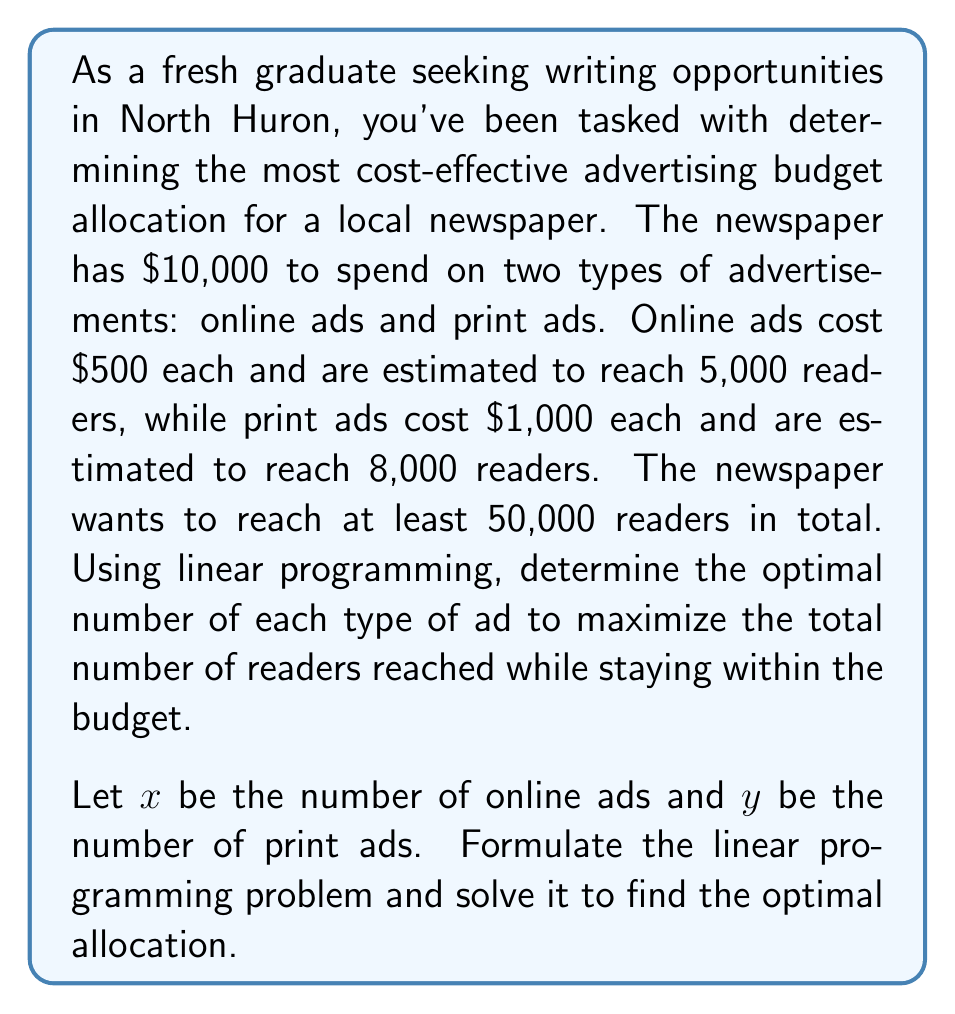Could you help me with this problem? To solve this linear programming problem, we'll follow these steps:

1. Define the objective function:
   Maximize $Z = 5000x + 8000y$ (total readers reached)

2. Identify the constraints:
   Budget constraint: $500x + 1000y \leq 10000$
   Minimum readers constraint: $5000x + 8000y \geq 50000$
   Non-negativity constraints: $x \geq 0$, $y \geq 0$

3. Graph the feasible region:
   We'll plot the constraints on a coordinate system with $x$ on the horizontal axis and $y$ on the vertical axis.

   [asy]
   import geometry;
   
   size(200);
   
   xlimits(0,25);
   ylimits(0,15);
   
   xaxis("x",Ticks());
   yaxis("y",Ticks());
   
   path budget = (0,10)--(20,0);
   path readers = (10,0)--(0,6.25);
   
   draw(budget,blue);
   draw(readers,red);
   
   label("Budget constraint",(-1,11),blue);
   label("Readers constraint",(12,5),red);
   
   fill((10,0)--(10,5)--(5,5)--(0,6.25)--(0,10)--(10,10)--cycle,palegreen+opacity(0.3));
   
   dot((10,5));
   label("(10,5)",(10,5),SE);
   [/asy]

4. Identify the corner points of the feasible region:
   (0,10), (10,5), (10,0), (0,6.25)

5. Evaluate the objective function at each corner point:
   At (0,10): $Z = 5000(0) + 8000(10) = 80000$
   At (10,5): $Z = 5000(10) + 8000(5) = 90000$
   At (10,0): $Z = 5000(10) + 8000(0) = 50000$
   At (0,6.25): $Z = 5000(0) + 8000(6.25) = 50000$

6. Determine the optimal solution:
   The maximum value of $Z$ occurs at the point (10,5), which represents 10 online ads and 5 print ads.

7. Verify the solution:
   Budget: $500(10) + 1000(5) = 10000$ (meets the budget constraint)
   Readers reached: $5000(10) + 8000(5) = 90000$ (exceeds the minimum requirement)

Therefore, the optimal allocation is 10 online ads and 5 print ads, reaching a total of 90,000 readers.
Answer: 10 online ads, 5 print ads 